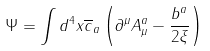<formula> <loc_0><loc_0><loc_500><loc_500>\Psi = \int d ^ { 4 } x \overline { c } _ { a } \left ( \partial ^ { \mu } A ^ { a } _ { \mu } - \frac { b ^ { a } } { 2 \xi } \right )</formula> 